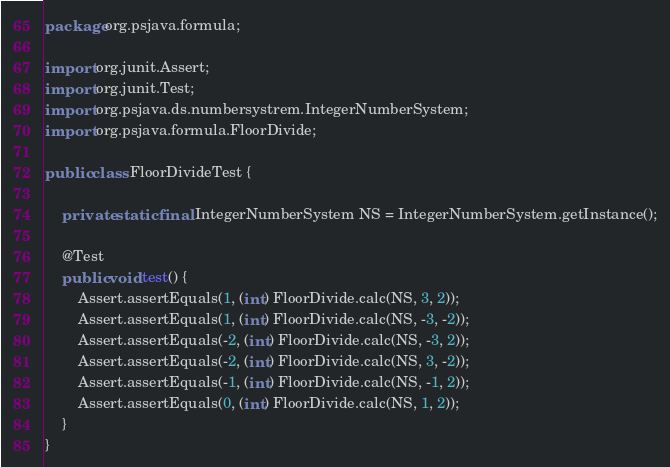Convert code to text. <code><loc_0><loc_0><loc_500><loc_500><_Java_>package org.psjava.formula;

import org.junit.Assert;
import org.junit.Test;
import org.psjava.ds.numbersystrem.IntegerNumberSystem;
import org.psjava.formula.FloorDivide;

public class FloorDivideTest {

    private static final IntegerNumberSystem NS = IntegerNumberSystem.getInstance();

    @Test
    public void test() {
        Assert.assertEquals(1, (int) FloorDivide.calc(NS, 3, 2));
        Assert.assertEquals(1, (int) FloorDivide.calc(NS, -3, -2));
        Assert.assertEquals(-2, (int) FloorDivide.calc(NS, -3, 2));
        Assert.assertEquals(-2, (int) FloorDivide.calc(NS, 3, -2));
        Assert.assertEquals(-1, (int) FloorDivide.calc(NS, -1, 2));
        Assert.assertEquals(0, (int) FloorDivide.calc(NS, 1, 2));
    }
}
</code> 